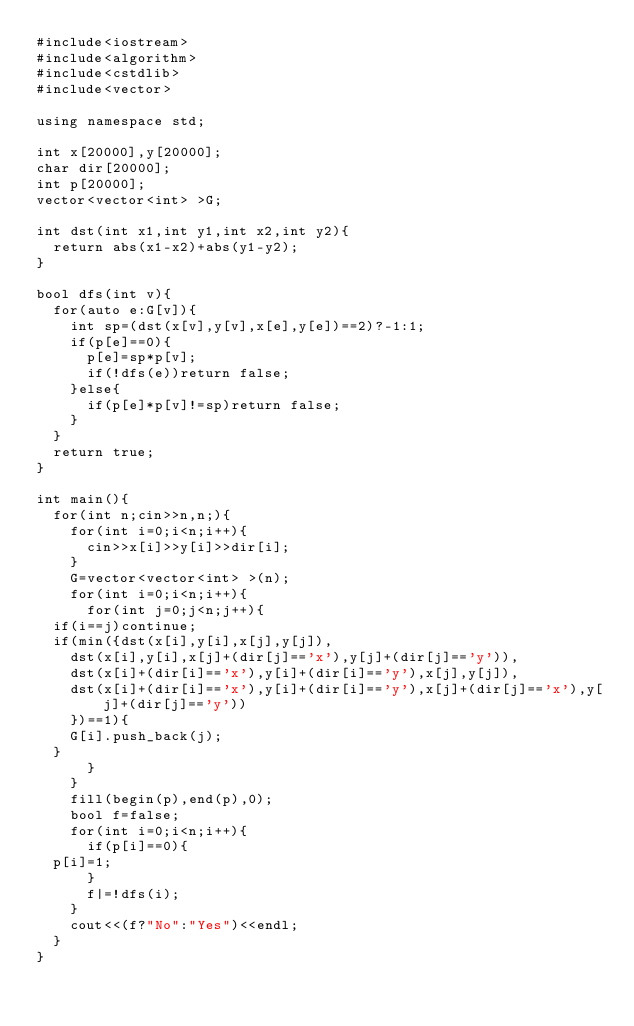<code> <loc_0><loc_0><loc_500><loc_500><_C++_>#include<iostream>
#include<algorithm>
#include<cstdlib>
#include<vector>

using namespace std;

int x[20000],y[20000];
char dir[20000];
int p[20000];
vector<vector<int> >G;

int dst(int x1,int y1,int x2,int y2){
  return abs(x1-x2)+abs(y1-y2);
}

bool dfs(int v){
  for(auto e:G[v]){
    int sp=(dst(x[v],y[v],x[e],y[e])==2)?-1:1;
    if(p[e]==0){
      p[e]=sp*p[v];
      if(!dfs(e))return false;
    }else{
      if(p[e]*p[v]!=sp)return false;
    }
  }
  return true;
}

int main(){
  for(int n;cin>>n,n;){
    for(int i=0;i<n;i++){
      cin>>x[i]>>y[i]>>dir[i];
    }
    G=vector<vector<int> >(n);
    for(int i=0;i<n;i++){
      for(int j=0;j<n;j++){
	if(i==j)continue;
	if(min({dst(x[i],y[i],x[j],y[j]),
		dst(x[i],y[i],x[j]+(dir[j]=='x'),y[j]+(dir[j]=='y')),
		dst(x[i]+(dir[i]=='x'),y[i]+(dir[i]=='y'),x[j],y[j]),
		dst(x[i]+(dir[i]=='x'),y[i]+(dir[i]=='y'),x[j]+(dir[j]=='x'),y[j]+(dir[j]=='y'))
		})==1){
	  G[i].push_back(j);
	}
      }
    }
    fill(begin(p),end(p),0);
    bool f=false;
    for(int i=0;i<n;i++){
      if(p[i]==0){
	p[i]=1;
      }
      f|=!dfs(i);
    }
    cout<<(f?"No":"Yes")<<endl;
  }
}  
    </code> 